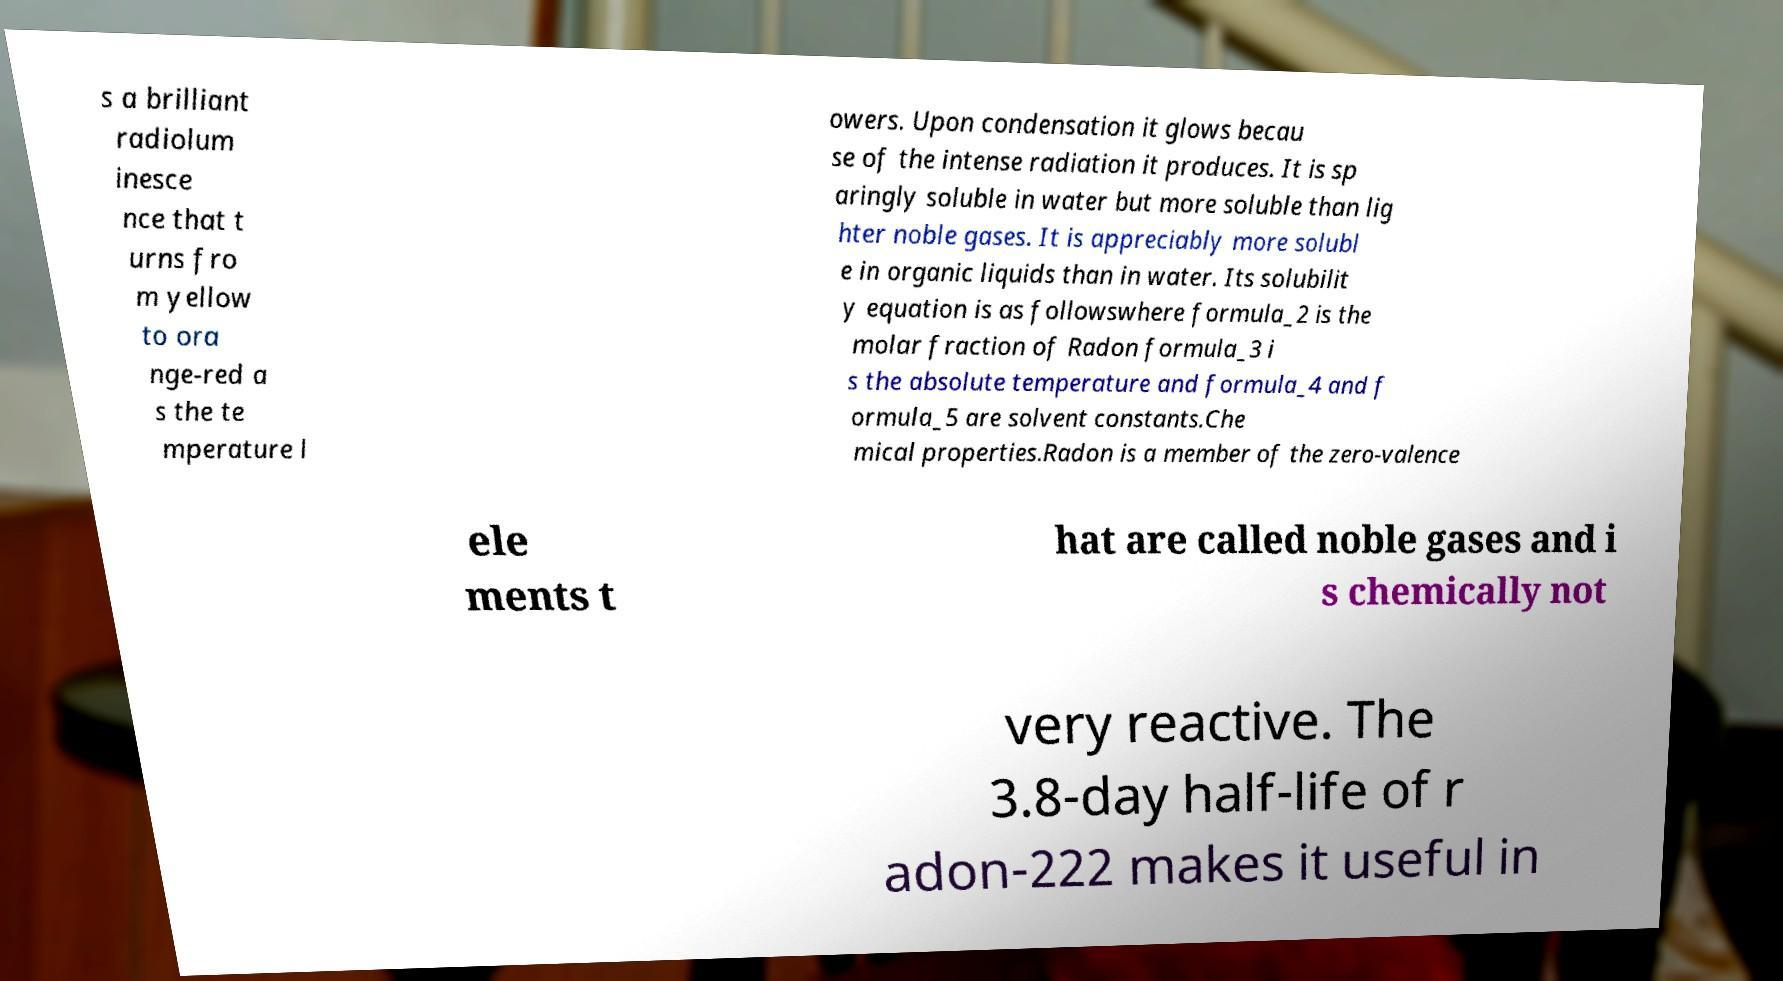Can you accurately transcribe the text from the provided image for me? s a brilliant radiolum inesce nce that t urns fro m yellow to ora nge-red a s the te mperature l owers. Upon condensation it glows becau se of the intense radiation it produces. It is sp aringly soluble in water but more soluble than lig hter noble gases. It is appreciably more solubl e in organic liquids than in water. Its solubilit y equation is as followswhere formula_2 is the molar fraction of Radon formula_3 i s the absolute temperature and formula_4 and f ormula_5 are solvent constants.Che mical properties.Radon is a member of the zero-valence ele ments t hat are called noble gases and i s chemically not very reactive. The 3.8-day half-life of r adon-222 makes it useful in 